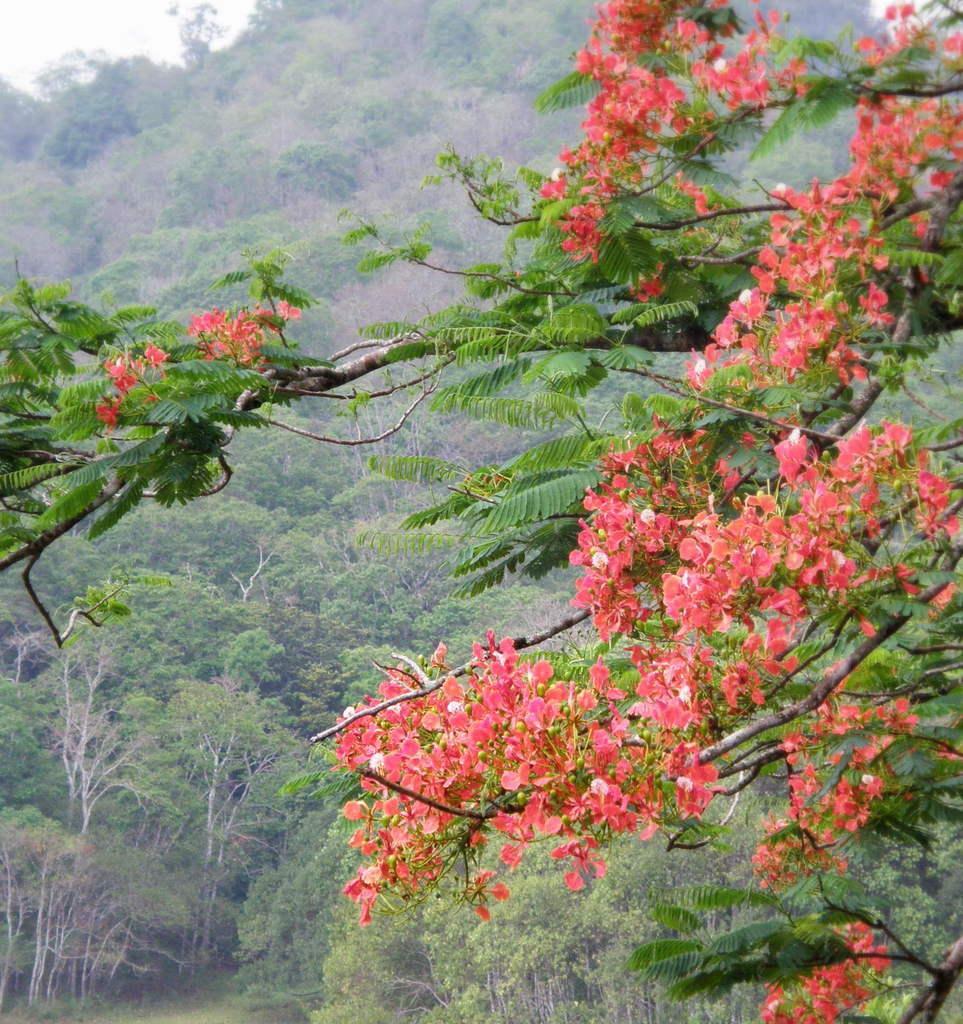How would you summarize this image in a sentence or two? In this image I can see flowers in peach color, background I can see trees in green color and the sky is in white color. 